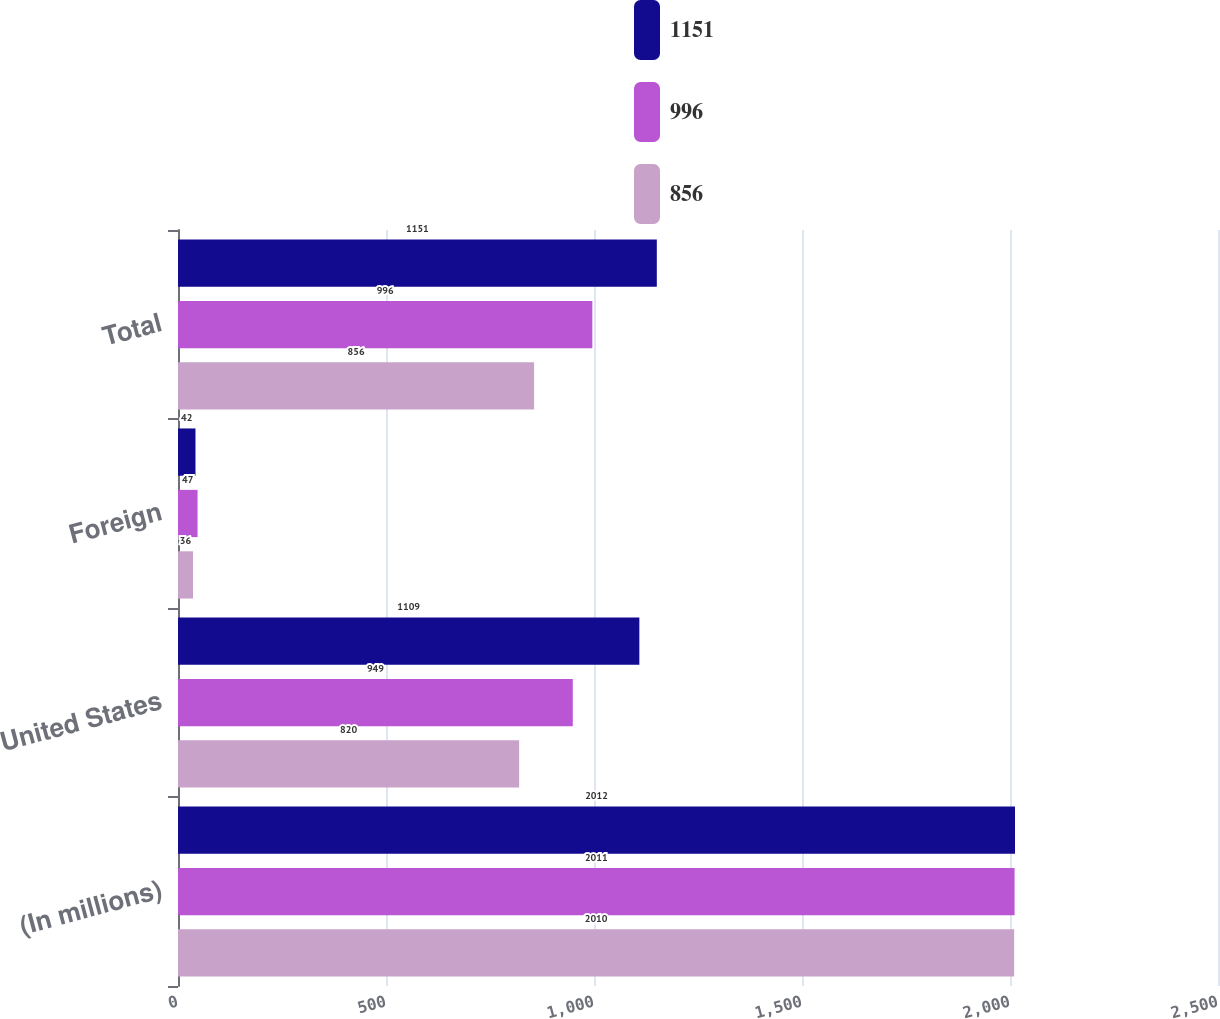Convert chart. <chart><loc_0><loc_0><loc_500><loc_500><stacked_bar_chart><ecel><fcel>(In millions)<fcel>United States<fcel>Foreign<fcel>Total<nl><fcel>1151<fcel>2012<fcel>1109<fcel>42<fcel>1151<nl><fcel>996<fcel>2011<fcel>949<fcel>47<fcel>996<nl><fcel>856<fcel>2010<fcel>820<fcel>36<fcel>856<nl></chart> 